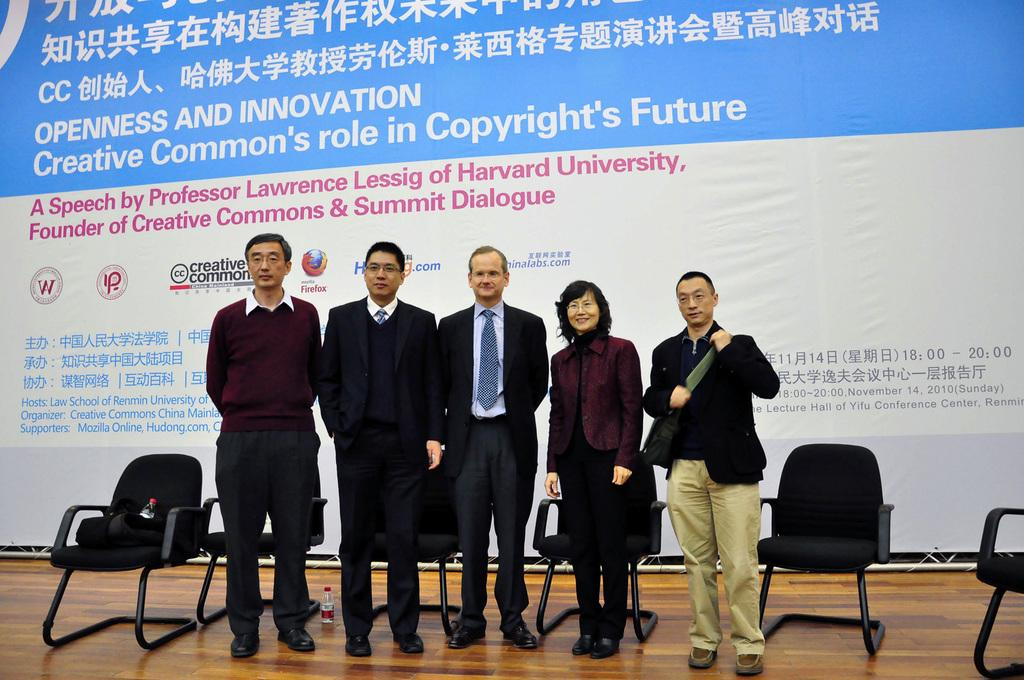What can be seen in the background of the image? There is a hoarding in the background of the image. What is located in the foreground of the image? There is a platform in the image. What is on the platform? There are chairs and a water bottle on the platform. Are there any people in the image? Yes, people are standing in the image. What type of system is being used by the man and fowl in the image? There is no man or fowl present in the image. 